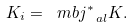Convert formula to latex. <formula><loc_0><loc_0><loc_500><loc_500>K _ { i } = \ m b { j } _ { \ a l } ^ { * } K .</formula> 